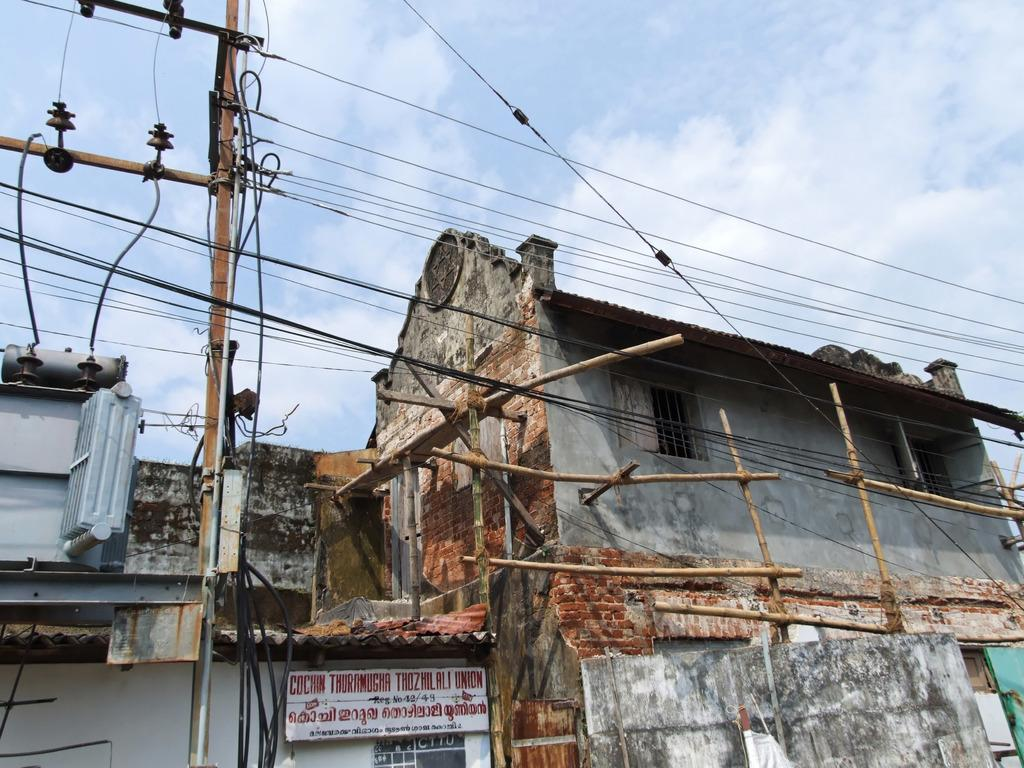What is the main subject of the image? The main subject of the image is a building under construction. What other objects can be seen in the image? There is a transformer, a pole, and wires in the image. Where are these objects located in the image? The transformer, pole, and wires are located in the left corner of the image. Who is the owner of the scale in the image? There is no scale present in the image. 